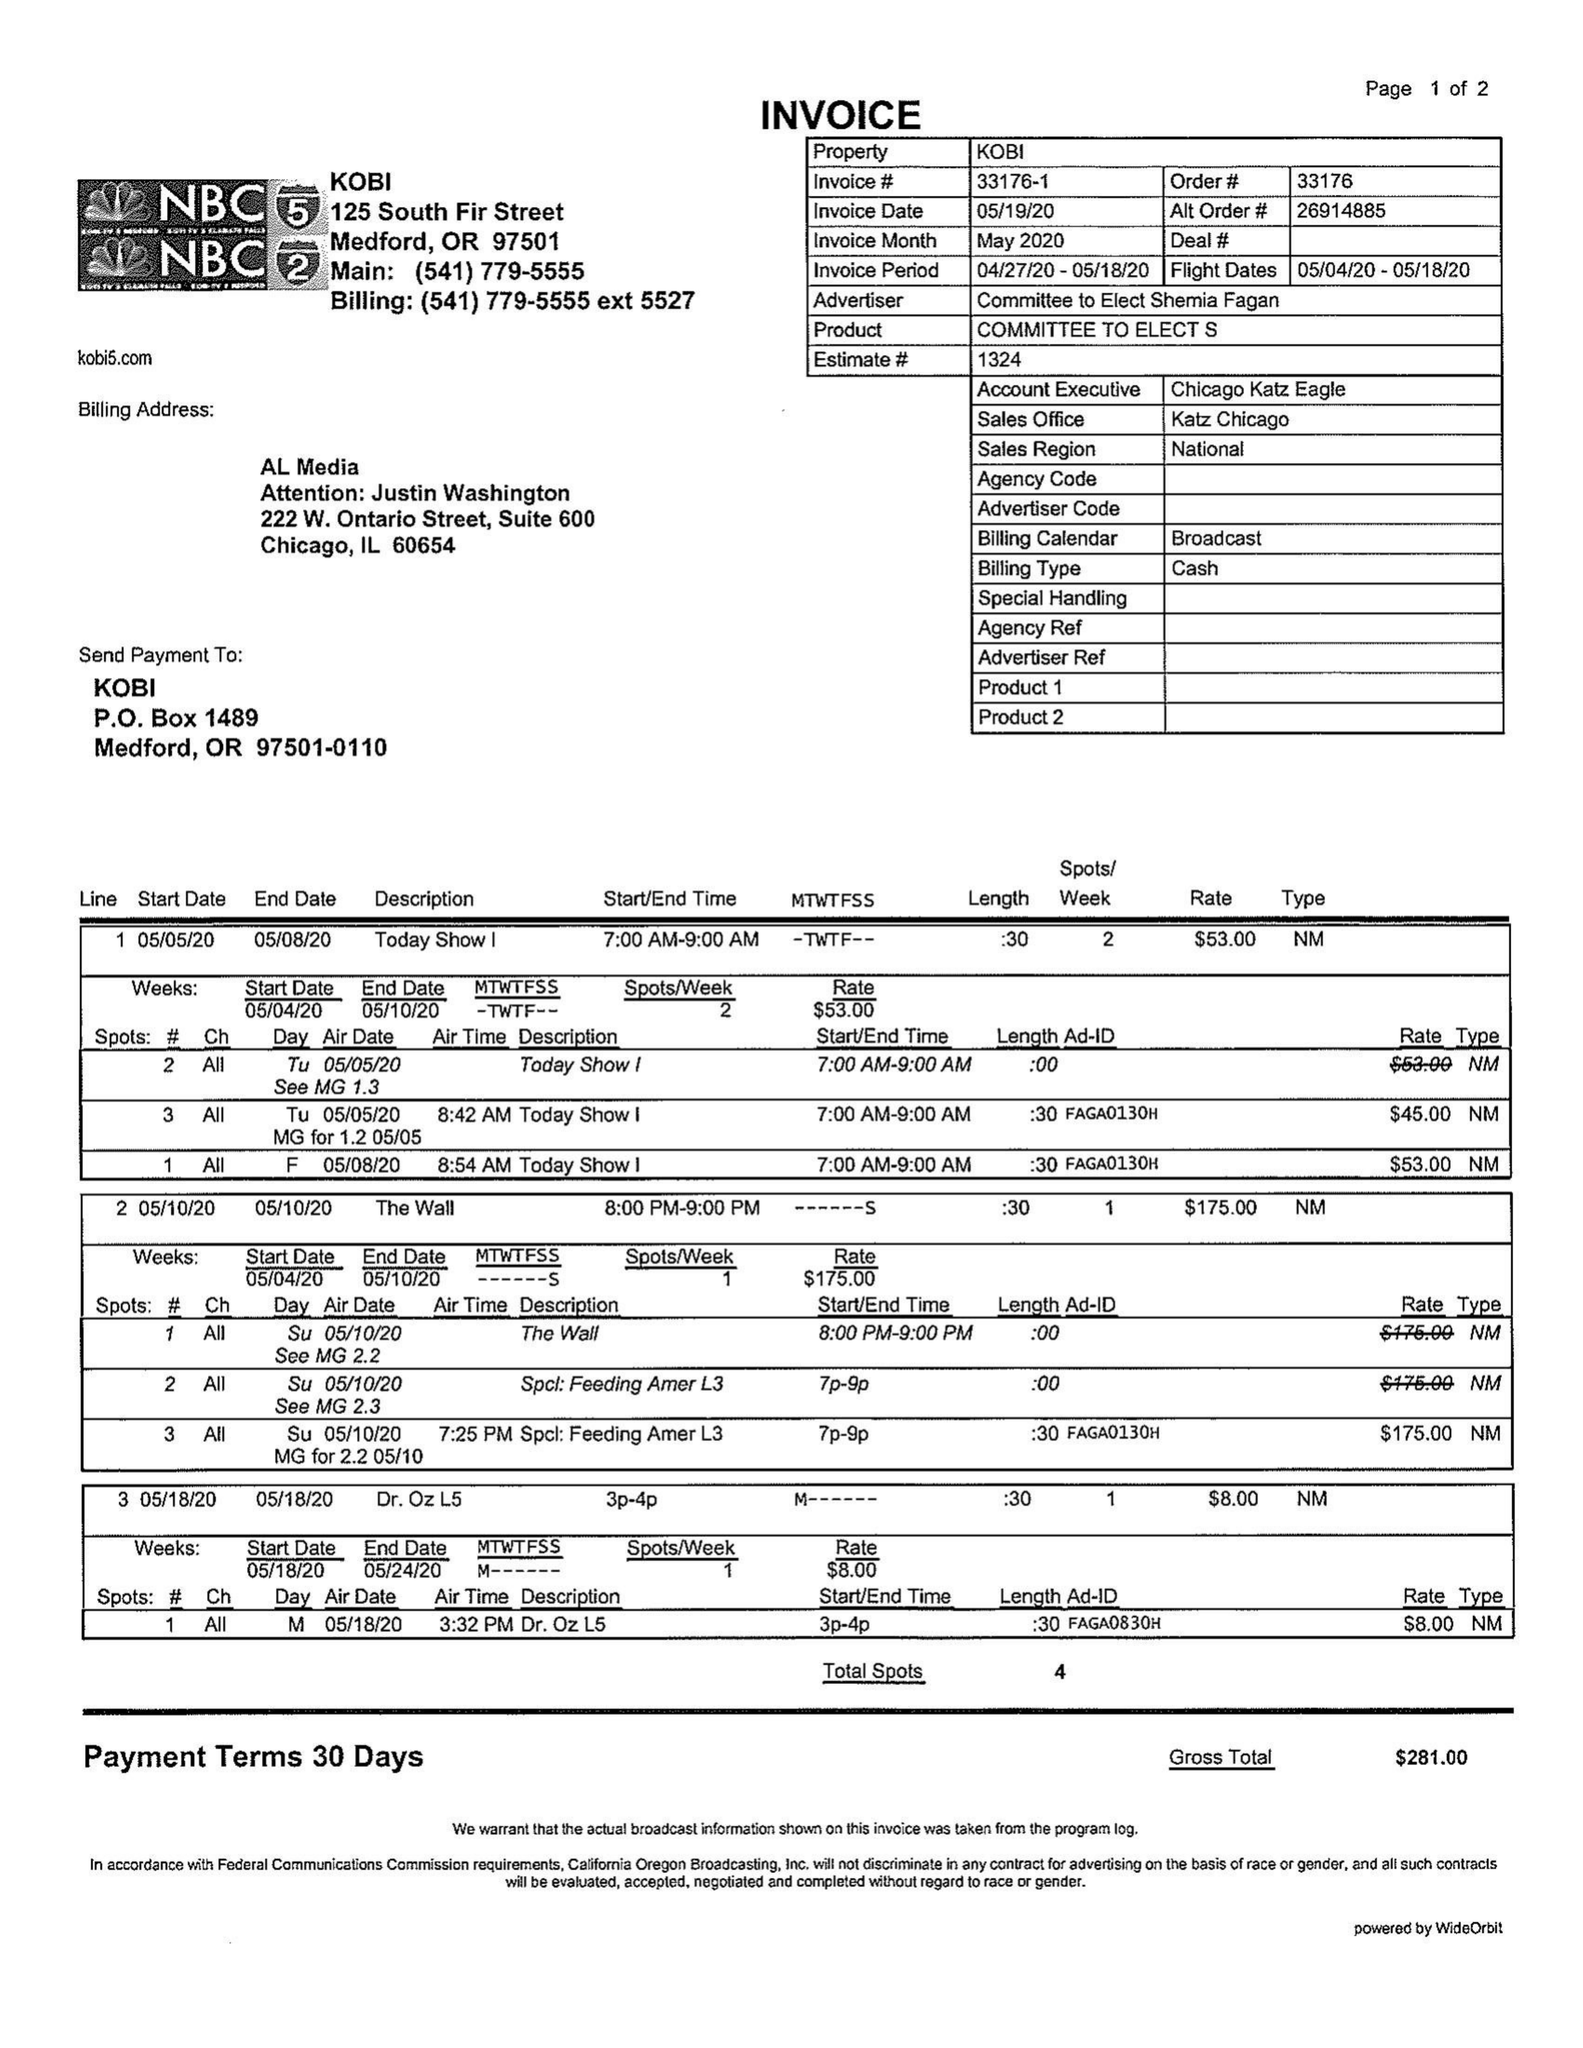What is the value for the flight_to?
Answer the question using a single word or phrase. 05/18/20 